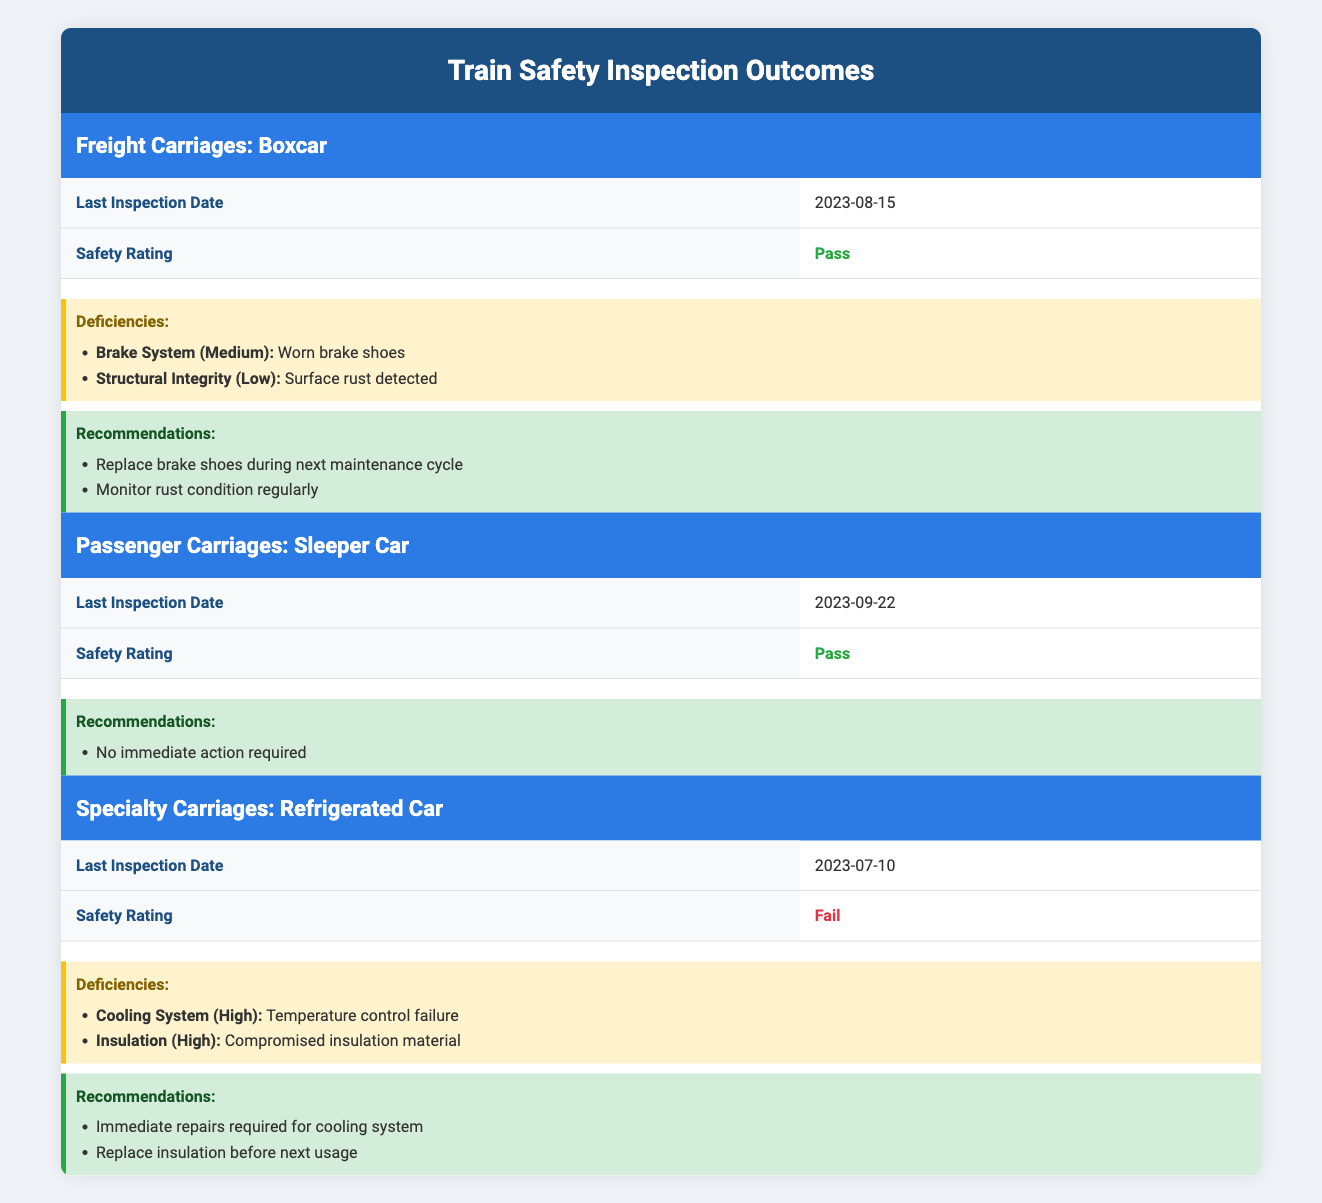What is the safety rating of the Freight Carriages? The table indicates that the safety rating for the Freight Carriages (Boxcar) is "Pass".
Answer: Pass When was the last inspection date for the Passenger Carriages? According to the table, the last inspection date for the Passenger Carriages (Sleeper Car) was on "2023-09-22".
Answer: 2023-09-22 How many deficiencies were found in the Refrigerated Car? The table shows that there are two deficiencies listed for the Specialty Carriages (Refrigerated Car): cooling system and insulation. Therefore, the count of deficiencies is 2.
Answer: 2 Is there any recommendation for the Freight Carriages? There are several recommendations for the Freight Carriages listed in the table: "Replace brake shoes during next maintenance cycle" and "Monitor rust condition regularly". Therefore, the answer is yes.
Answer: Yes What is the severity level of the deficiency related to the brake system in the Freight Carriages? The table specifies that the deficiency type "Brake System" has a severity level labeled as "Medium".
Answer: Medium Compare the safety ratings of Passenger Carriages and Specialty Carriages. The Passenger Carriages (Sleeper Car) have a safety rating of "Pass", while the Specialty Carriages (Refrigerated Car) have a safety rating of "Fail". The difference is significant, indicating that one passed inspection while the other failed.
Answer: Passenger Carriages passed, Specialty Carriages failed What specific actions are recommended for the Specialty Carriages following its inspection? The recommendations for the Specialty Carriages (Refrigerated Car) include: "Immediate repairs required for cooling system" and "Replace insulation before next usage". These repairs are critical and need to be addressed promptly.
Answer: Immediate repairs required Which carriage type has the highest severity deficiency? The Specialty Carriages (Refrigerated Car) have deficiencies categorized as "High" for both the cooling system and insulation. Thus, it possesses the highest severity level of deficiencies when compared to others.
Answer: Refrigerated Car What is the last inspection date for the Freight Carriages? The table states the last inspection date for the Freight Carriages (Boxcar) was "2023-08-15", indicating recent inspection activities.
Answer: 2023-08-15 